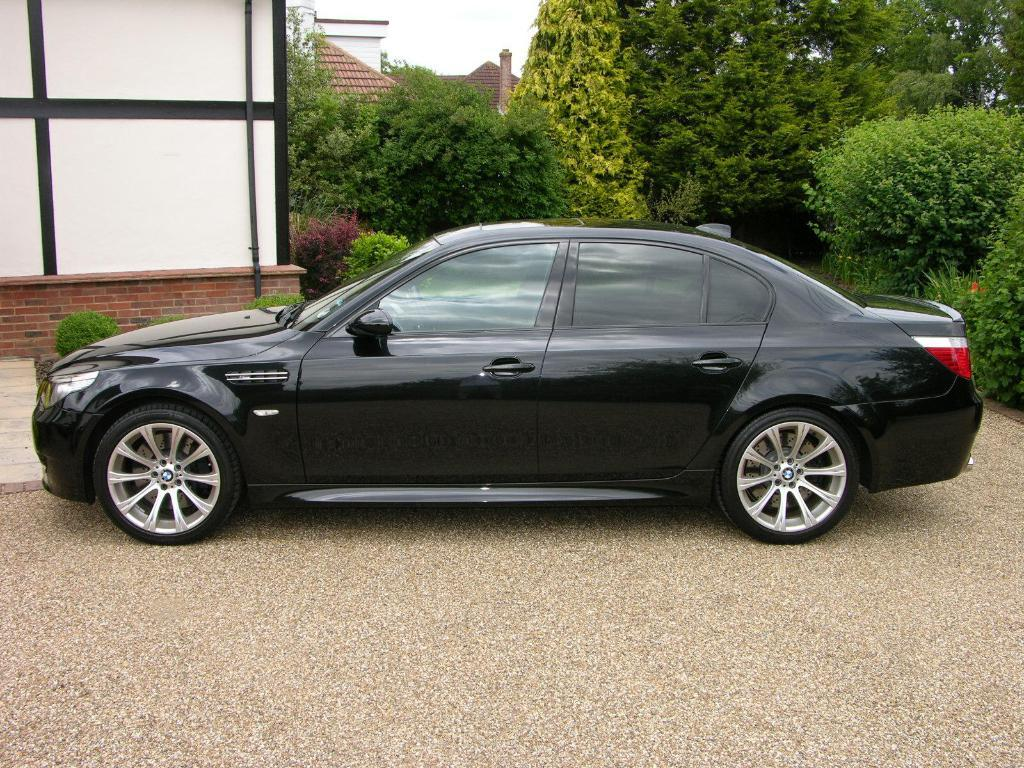What is the main subject of the image? The main subject of the image is a car. Can you describe the car in the image? The car is black. What can be seen in the background of the image? There are trees, a board, and the sky visible in the background. How are the trees and board described in the image? The trees are green, and the board is white. What is the color of the sky in the image? The sky appears to be white in the image. Where is the art collection stored in the image? There is no mention of an art collection or a storage location in the image. 